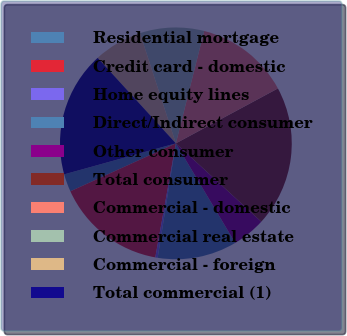Convert chart. <chart><loc_0><loc_0><loc_500><loc_500><pie_chart><fcel>Residential mortgage<fcel>Credit card - domestic<fcel>Home equity lines<fcel>Direct/Indirect consumer<fcel>Other consumer<fcel>Total consumer<fcel>Commercial - domestic<fcel>Commercial real estate<fcel>Commercial - foreign<fcel>Total commercial (1)<nl><fcel>2.48%<fcel>15.37%<fcel>0.33%<fcel>11.07%<fcel>4.63%<fcel>19.67%<fcel>13.22%<fcel>8.93%<fcel>6.78%<fcel>17.52%<nl></chart> 